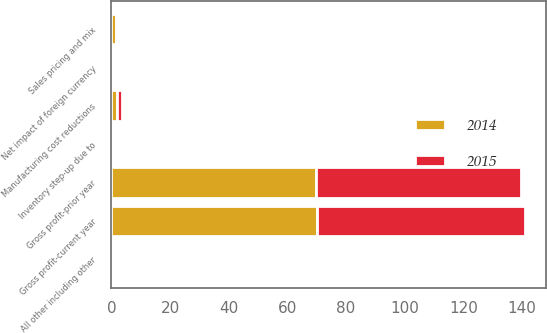Convert chart to OTSL. <chart><loc_0><loc_0><loc_500><loc_500><stacked_bar_chart><ecel><fcel>Gross profit-prior year<fcel>Manufacturing cost reductions<fcel>Sales pricing and mix<fcel>Inventory step-up due to<fcel>Net impact of foreign currency<fcel>All other including other<fcel>Gross profit-current year<nl><fcel>2015<fcel>70.1<fcel>1.8<fcel>0.6<fcel>0.4<fcel>0.5<fcel>0.5<fcel>70.9<nl><fcel>2014<fcel>69.6<fcel>1.8<fcel>1.5<fcel>0.1<fcel>0.2<fcel>0.3<fcel>70.1<nl></chart> 